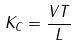Convert formula to latex. <formula><loc_0><loc_0><loc_500><loc_500>K _ { C } = \frac { V T } { L }</formula> 